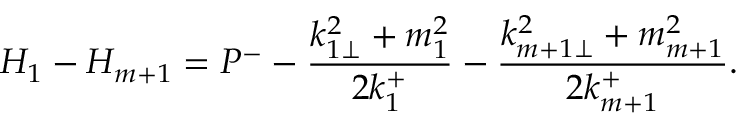<formula> <loc_0><loc_0><loc_500><loc_500>H _ { 1 } - H _ { m + 1 } = P ^ { - } - \frac { k _ { 1 \perp } ^ { 2 } + m _ { 1 } ^ { 2 } } { 2 k _ { 1 } ^ { + } } - \frac { k _ { m + 1 \perp } ^ { 2 } + m _ { m + 1 } ^ { 2 } } { 2 k _ { m + 1 } ^ { + } } .</formula> 